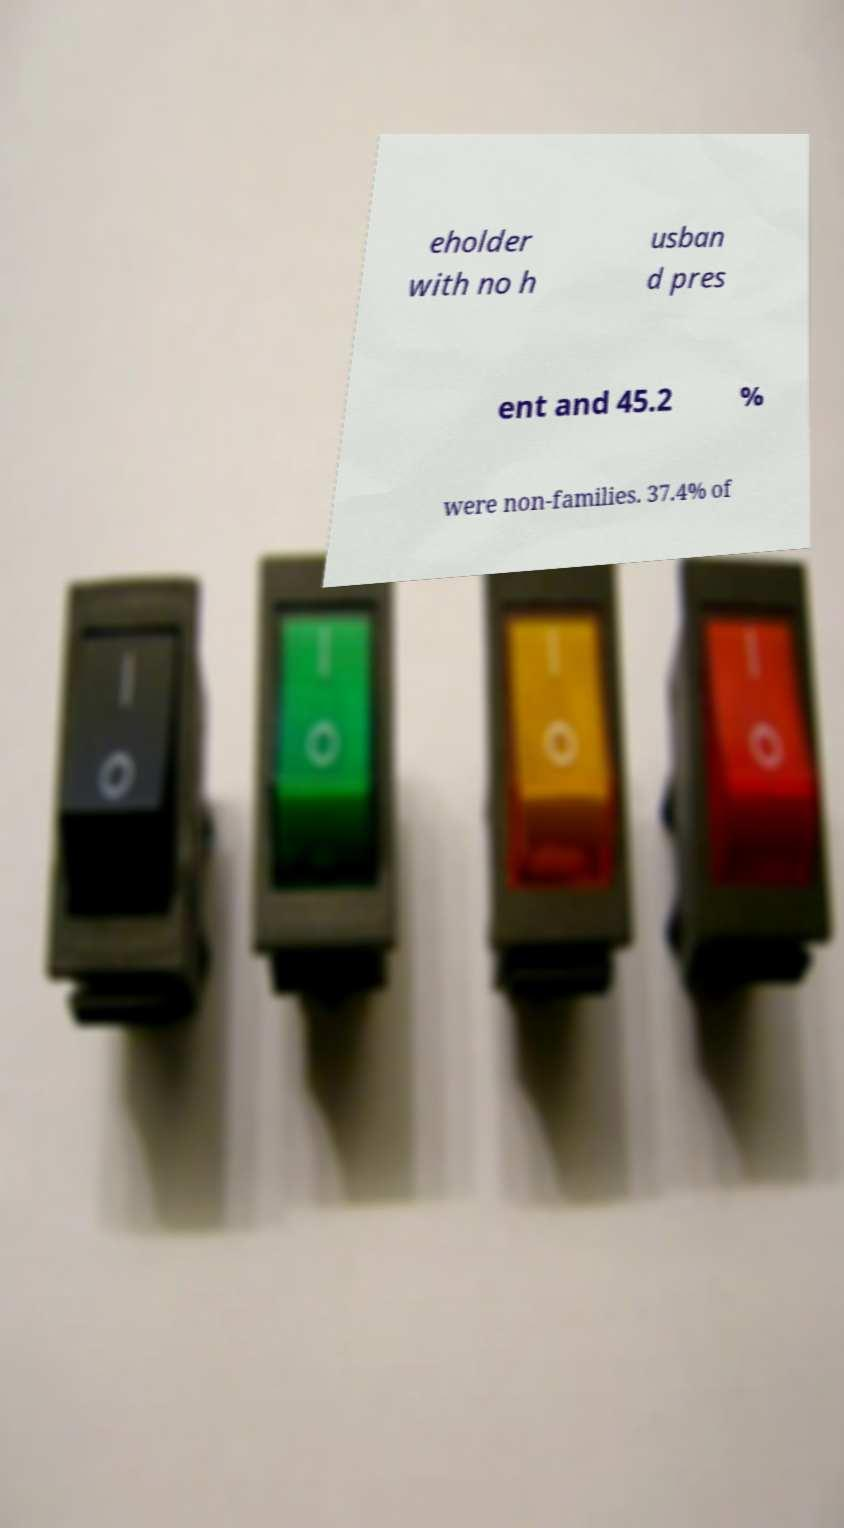For documentation purposes, I need the text within this image transcribed. Could you provide that? eholder with no h usban d pres ent and 45.2 % were non-families. 37.4% of 